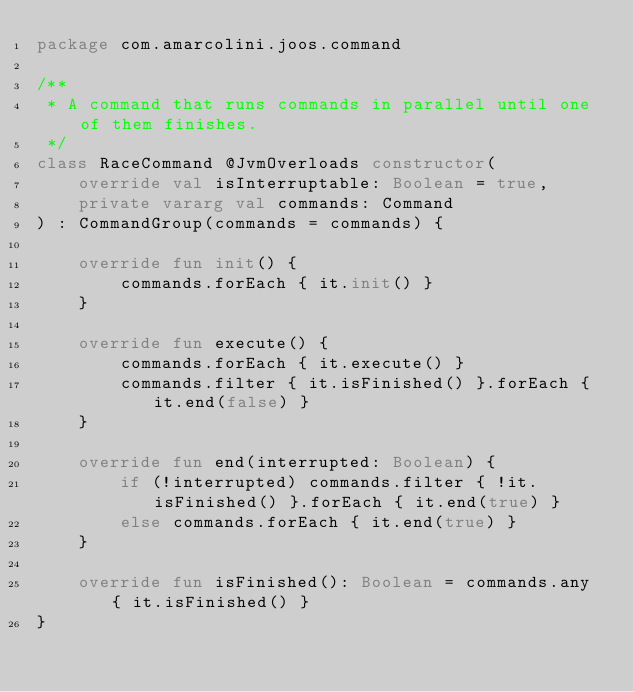<code> <loc_0><loc_0><loc_500><loc_500><_Kotlin_>package com.amarcolini.joos.command

/**
 * A command that runs commands in parallel until one of them finishes.
 */
class RaceCommand @JvmOverloads constructor(
    override val isInterruptable: Boolean = true,
    private vararg val commands: Command
) : CommandGroup(commands = commands) {

    override fun init() {
        commands.forEach { it.init() }
    }

    override fun execute() {
        commands.forEach { it.execute() }
        commands.filter { it.isFinished() }.forEach { it.end(false) }
    }

    override fun end(interrupted: Boolean) {
        if (!interrupted) commands.filter { !it.isFinished() }.forEach { it.end(true) }
        else commands.forEach { it.end(true) }
    }

    override fun isFinished(): Boolean = commands.any { it.isFinished() }
}</code> 